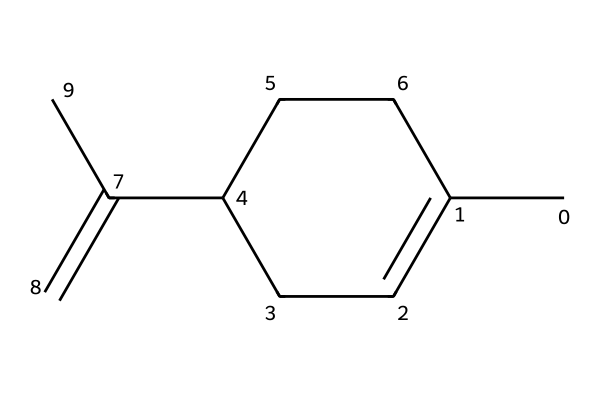What is the molecular formula of limonene? To find the molecular formula, count the number of each type of atom in the SMILES representation. The structure includes 10 carbon atoms and 16 hydrogen atoms. Thus, the molecular formula is C10H16.
Answer: C10H16 How many chiral centers are in limonene? A chiral center is identified by a carbon atom that has four different substituents. By examining the molecular structure from the SMILES, there is one carbon atom that has four unique groups attached to it, indicating one chiral center.
Answer: 1 What is the common source of limonene? Limonene is predominantly found in citrus fruits, which are known for their flavorful oils. The SMILES representation indicates a structure that corresponds to those fragrant compounds found in the rinds of these fruits.
Answer: citrus fruits What type of compound is limonene? Limonene is classified as a monoterpene, which are hydrocarbons made up of two isoprene units. The structure shows a cyclic and unsaturated framework typical of terpenes.
Answer: monoterpene What characteristic does the presence of a chiral center impart to limonene? The presence of a chiral center means that limonene can exist in two enantiomeric forms, which have different spatial arrangements. This results in the two enantiomers having different sensory properties, such as fragrance.
Answer: enantiomers What type of bonds are predominantly present in limonene? The structure in the SMILES representation contains carbon-carbon single bonds and carbon-carbon double bonds. This indicates a presence of both single and double bonds typical for alkenes and cyclic compounds.
Answer: single and double bonds 